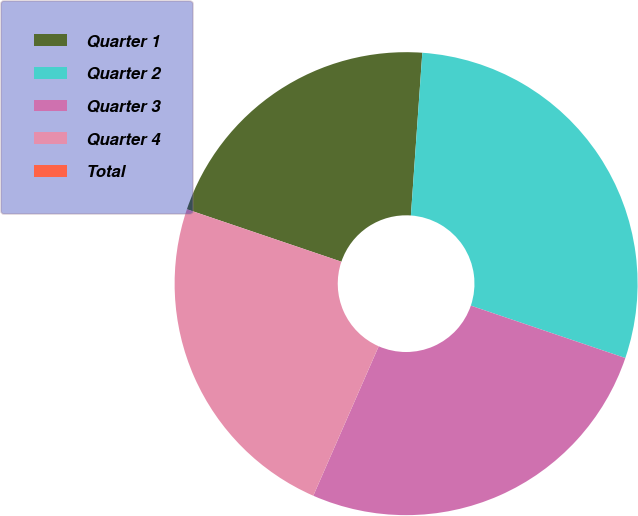Convert chart. <chart><loc_0><loc_0><loc_500><loc_500><pie_chart><fcel>Quarter 1<fcel>Quarter 2<fcel>Quarter 3<fcel>Quarter 4<fcel>Total<nl><fcel>20.91%<fcel>29.09%<fcel>26.36%<fcel>23.64%<fcel>0.0%<nl></chart> 